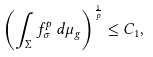<formula> <loc_0><loc_0><loc_500><loc_500>\left ( \int _ { \Sigma } f _ { \sigma } ^ { p } \, d \mu _ { g } \right ) ^ { \frac { 1 } { p } } \leq C _ { 1 } ,</formula> 